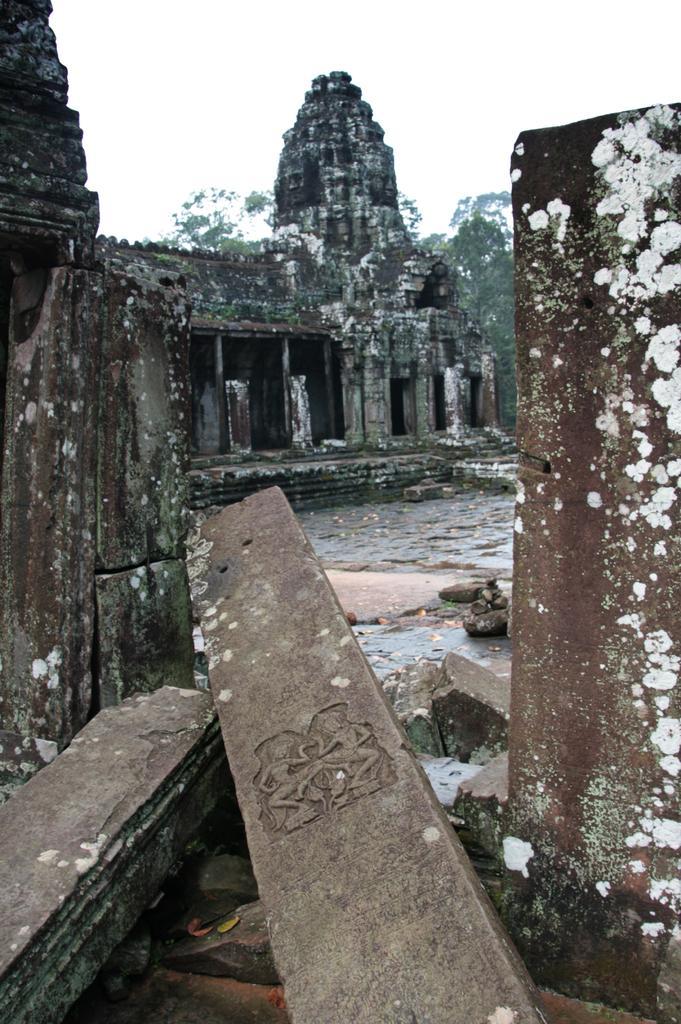Could you give a brief overview of what you see in this image? In this image we can see an ancient building, there are some trees, stones and pillars, in the background, we can see the sky. 